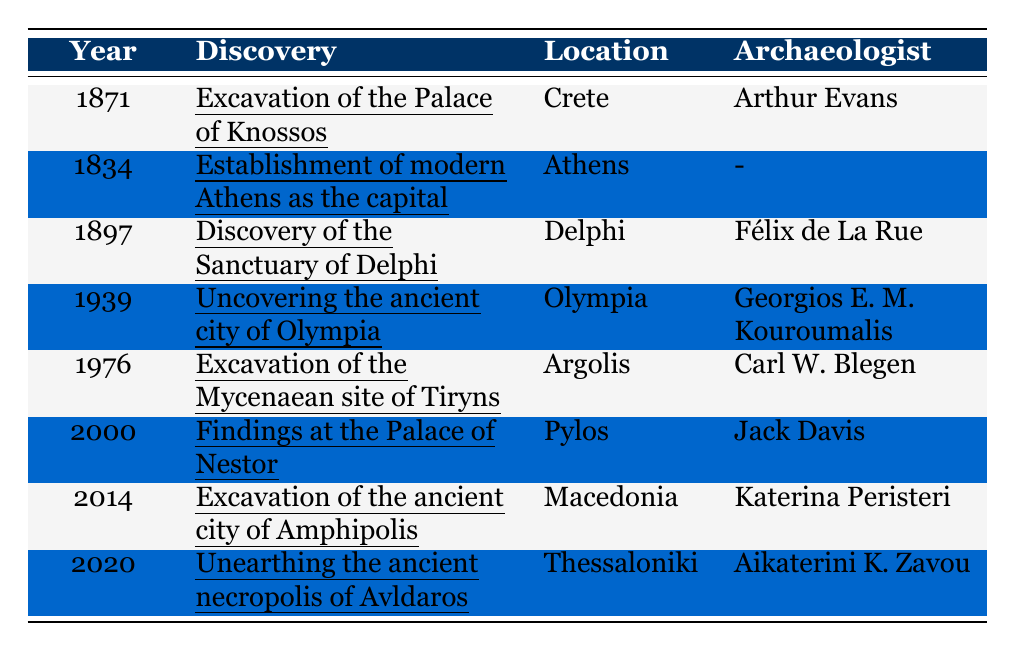What year did the excavation of the Palace of Knossos take place? Looking at the table, the excavation of the Palace of Knossos is listed under the year 1871.
Answer: 1871 Who discovered the Sanctuary of Delphi? From the table, the Sanctuary of Delphi was discovered by Félix de La Rue.
Answer: Félix de La Rue In which location was the ancient city of Olympia uncovered? The table specifies that the ancient city of Olympia was uncovered in Olympia.
Answer: Olympia What is the most recent archaeological discovery listed in the table? The most recent discovery mentioned in the table is the unearthing of the ancient necropolis of Avldaros in 2020.
Answer: Unearthing the ancient necropolis of Avldaros Which archaeologist conducted the excavation of the Mycenaean site of Tiryns? According to the table, Carl W. Blegen was responsible for the excavation of the Mycenaean site of Tiryns.
Answer: Carl W. Blegen Determine the total number of archaeological discoveries listed in the table. The table has 8 entries, which represent the total number of archaeological discoveries.
Answer: 8 Did any archaeological discoveries happen in the 19th century? Yes, the excavation of the Palace of Knossos in 1871 and the discovery of the Sanctuary of Delphi in 1897 occurred in the 19th century.
Answer: Yes Which archaeological discovery took place in Athens? The establishment of modern Athens as the capital is the only archaeological discovery listed that took place in Athens.
Answer: Establishment of modern Athens as the capital Identify the archaeologist associated with the findings at the Palace of Nestor. The table indicates that Jack Davis is the archaeologist associated with the findings at the Palace of Nestor.
Answer: Jack Davis How many discoveries were made before 1900? In the table, there are 3 discoveries listed before 1900: the establishment of modern Athens, the excavation of the Palace of Knossos, and the discovery of the Sanctuary of Delphi.
Answer: 3 What was the significance of establishing modern Athens as the capital? The significance mentioned in the table states that it focused on archaeological excavations within the city.
Answer: Focus on archaeological excavations within the city What is the average year of the discoveries listed in the table? To find the average year, we sum all years (1871 + 1834 + 1897 + 1939 + 1976 + 2000 + 2014 + 2020 = 14362) and divide by the number of discoveries (8). This results in 14362 / 8 = 1795.25, which rounds to 1795. The average year is approximately 1990.
Answer: 1990 Is there any archaeological discovery in Thessaloniki? Yes, the table indicates the unearthing of the ancient necropolis of Avldaros took place in Thessaloniki.
Answer: Yes Which archaeologist's work was last in the timeline? The table shows that Aikaterini K. Zavou’s work, related to the unearthing of the ancient necropolis of Avldaros, is the last in the timeline (2020).
Answer: Aikaterini K. Zavou What was discovered in 1897? The year 1897 corresponds to the discovery of the Sanctuary of Delphi.
Answer: Sanctuary of Delphi Which two locations mentioned in the table have discoveries attributed to more than one archaeologist? The table does not indicate any locations with discoveries credited to more than one archaeologist, as each listed discovery has a single archaeologist associated with it.
Answer: None 